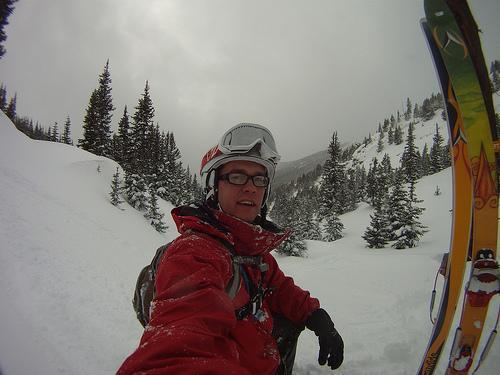How many people are there?
Give a very brief answer. 1. 